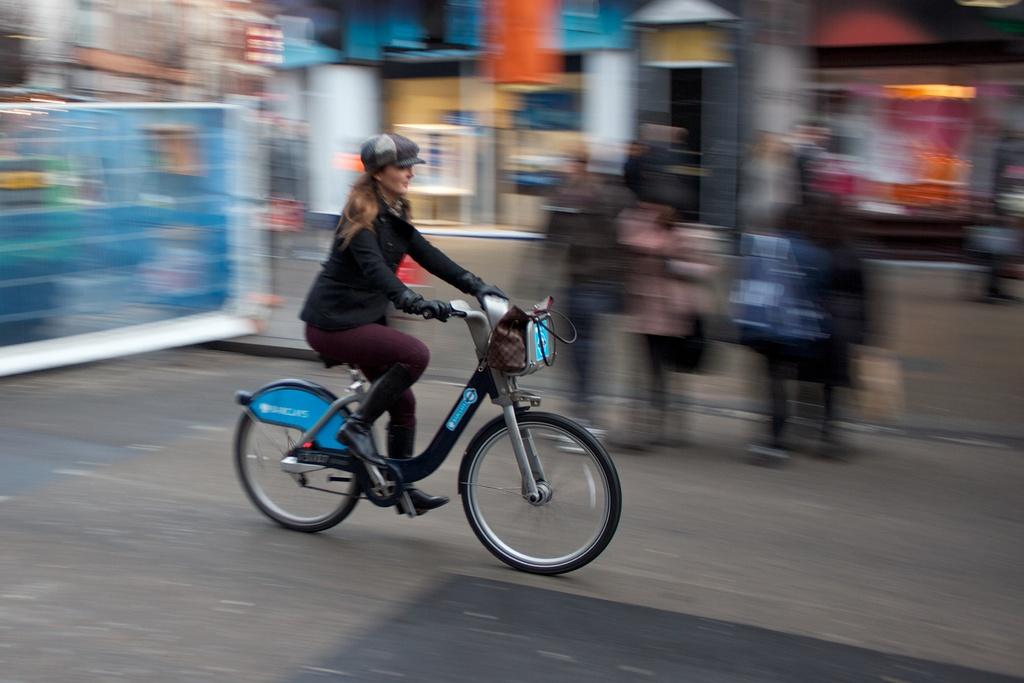Who is the main subject in the image? There is a woman in the image. What is the woman doing in the image? The woman is riding a bicycle. Where is the bicycle located in the image? The bicycle is on the road. Can you describe the background of the image? The background of the image appears blurry. How many legs does the tank have in the image? There is no tank present in the image. 